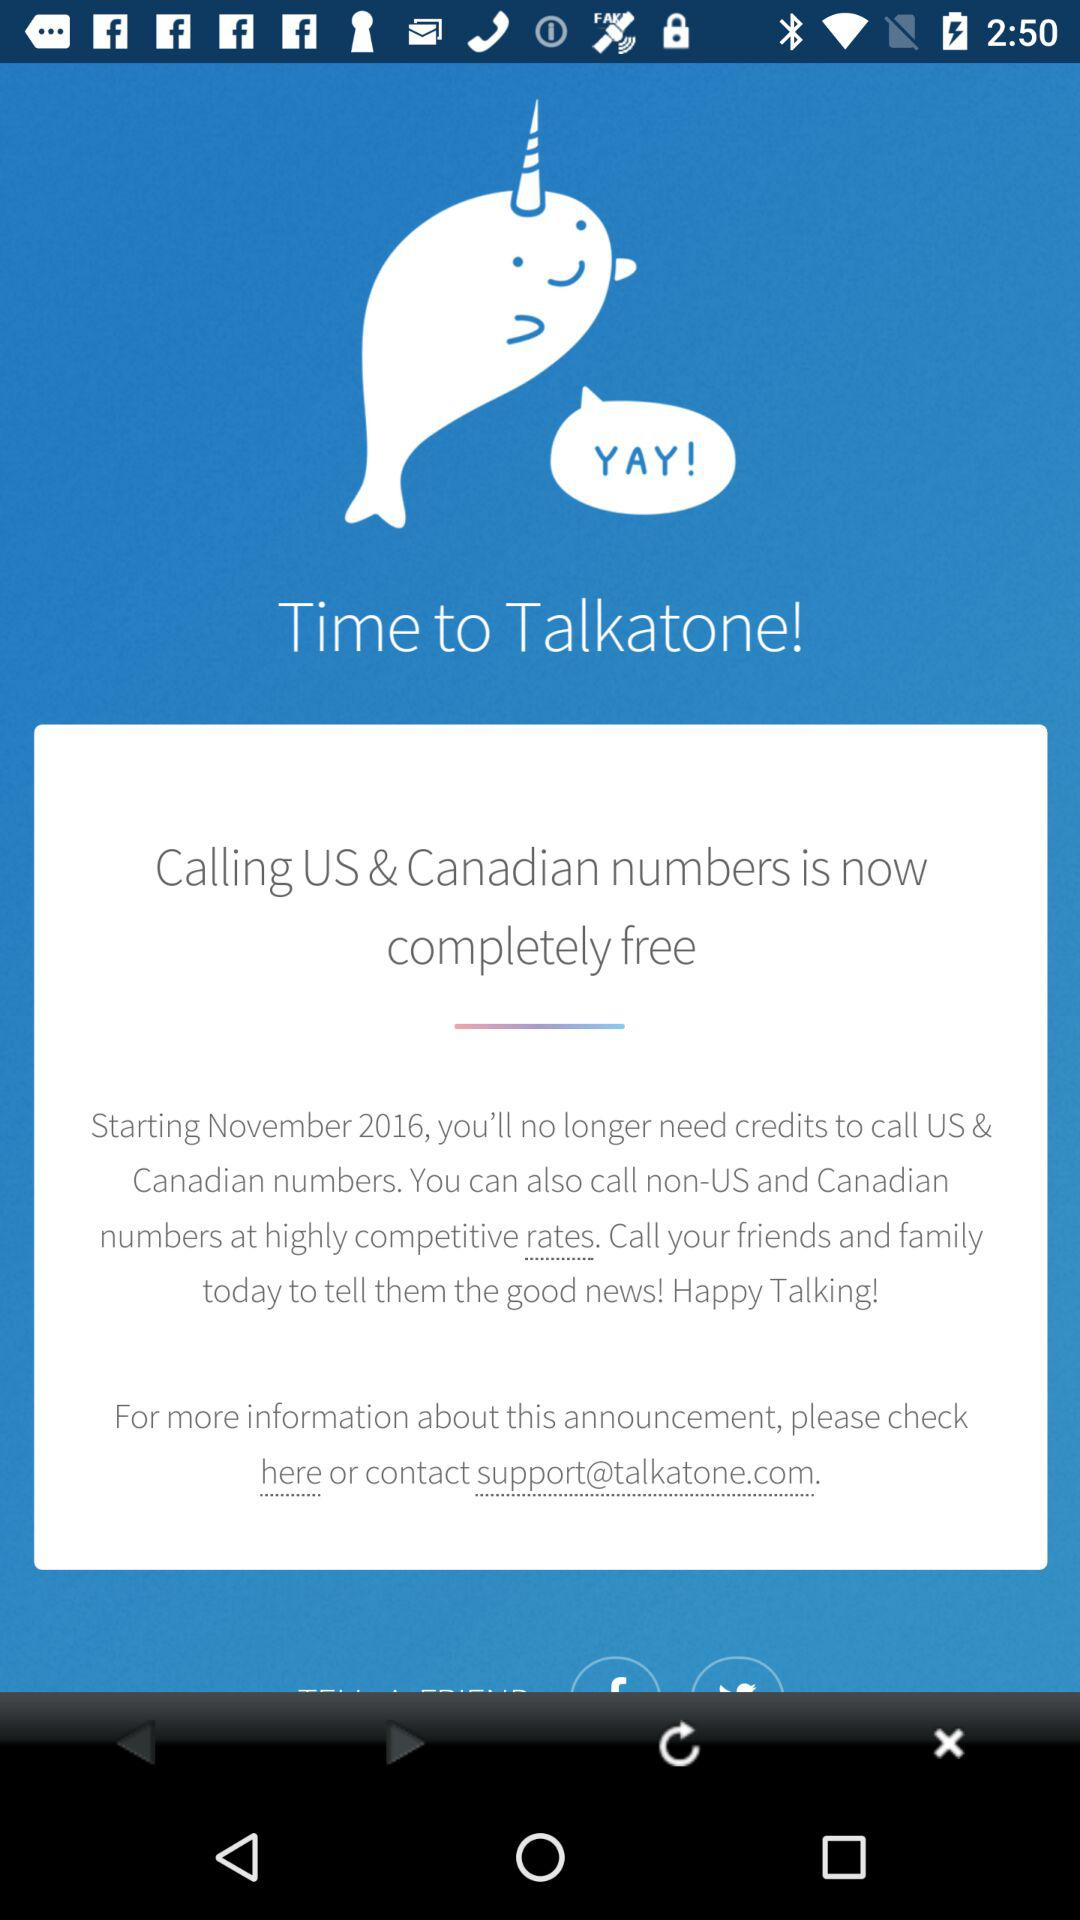In which countries is number-calling completely free now? The number-calling is now completely free in the US and Canada. 